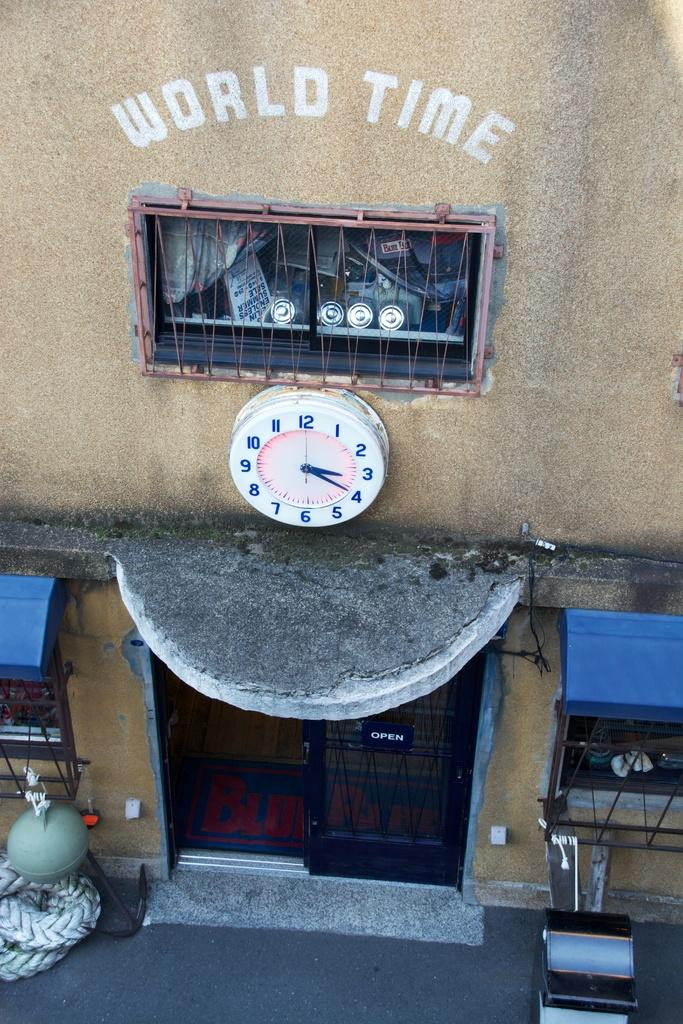<image>
Give a short and clear explanation of the subsequent image. The words World Time written on a wall above an analog clock. 